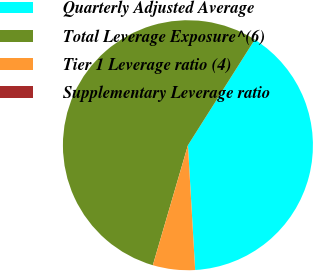Convert chart to OTSL. <chart><loc_0><loc_0><loc_500><loc_500><pie_chart><fcel>Quarterly Adjusted Average<fcel>Total Leverage Exposure^(6)<fcel>Tier 1 Leverage ratio (4)<fcel>Supplementary Leverage ratio<nl><fcel>40.1%<fcel>54.45%<fcel>5.45%<fcel>0.0%<nl></chart> 